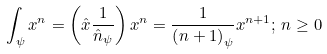Convert formula to latex. <formula><loc_0><loc_0><loc_500><loc_500>\int _ { \psi } { x ^ { n } } = \left ( { \hat { x } \frac { 1 } { { \hat { n } _ { \psi } } } } \right ) x ^ { n } = \frac { 1 } { { \left ( { n + 1 } \right ) _ { \psi } } } x ^ { n + 1 } ; \, n \geq 0</formula> 